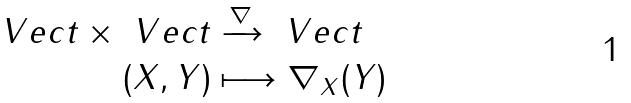<formula> <loc_0><loc_0><loc_500><loc_500>\ V e c t \times \ V e c t & \xrightarrow { \nabla } \ V e c t \\ ( X , Y ) & \longmapsto \nabla _ { X } ( Y )</formula> 